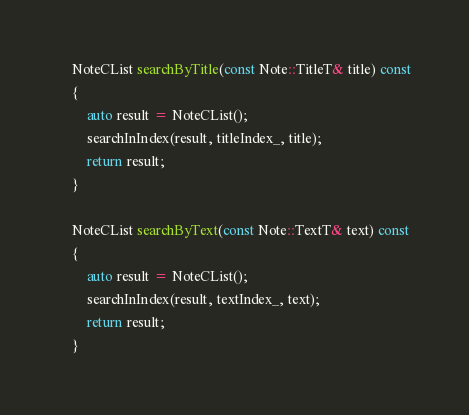Convert code to text. <code><loc_0><loc_0><loc_500><loc_500><_C++_>
	NoteCList searchByTitle(const Note::TitleT& title) const
	{
		auto result = NoteCList();
		searchInIndex(result, titleIndex_, title);
		return result;
	}

	NoteCList searchByText(const Note::TextT& text) const
	{
		auto result = NoteCList();
		searchInIndex(result, textIndex_, text);
		return result;
	}
</code> 